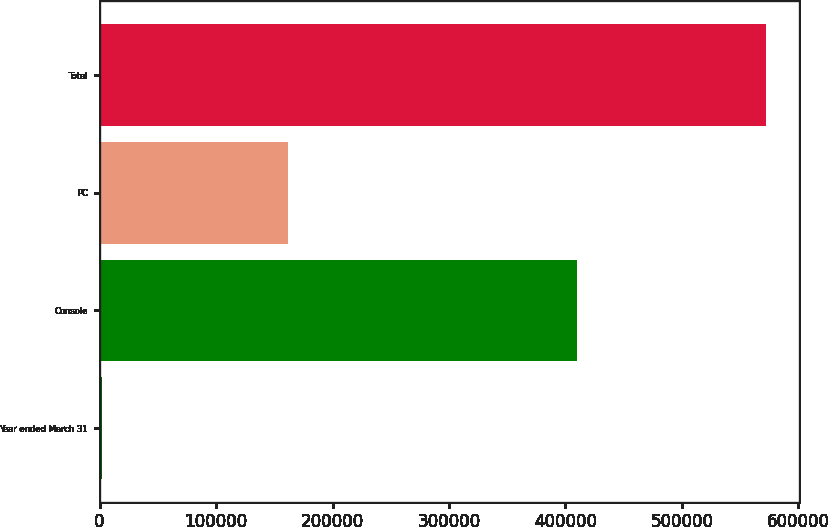<chart> <loc_0><loc_0><loc_500><loc_500><bar_chart><fcel>Year ended March 31<fcel>Console<fcel>PC<fcel>Total<nl><fcel>2000<fcel>410277<fcel>161928<fcel>572205<nl></chart> 